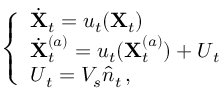Convert formula to latex. <formula><loc_0><loc_0><loc_500><loc_500>\left \{ \begin{array} { l l } { \dot { \mathbf X } _ { t } = { \boldsymbol u } _ { t } ( { \mathbf X } _ { t } ) } \\ { \dot { \mathbf X } _ { t } ^ { ( a ) } = { \boldsymbol u } _ { t } ( { \mathbf X } _ { t } ^ { ( a ) } ) + { \boldsymbol U } _ { t } } \\ { { \boldsymbol U } _ { t } = V _ { s } \hat { \boldsymbol n } _ { t } \, , } \end{array}</formula> 